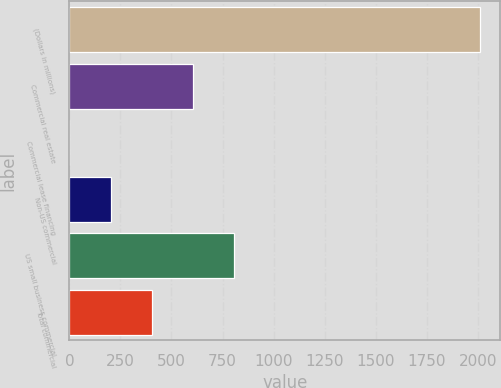Convert chart. <chart><loc_0><loc_0><loc_500><loc_500><bar_chart><fcel>(Dollars in millions)<fcel>Commercial real estate<fcel>Commercial lease financing<fcel>Non-US commercial<fcel>US small business commercial<fcel>Total commercial<nl><fcel>2010<fcel>603.18<fcel>0.27<fcel>201.24<fcel>804.15<fcel>402.21<nl></chart> 